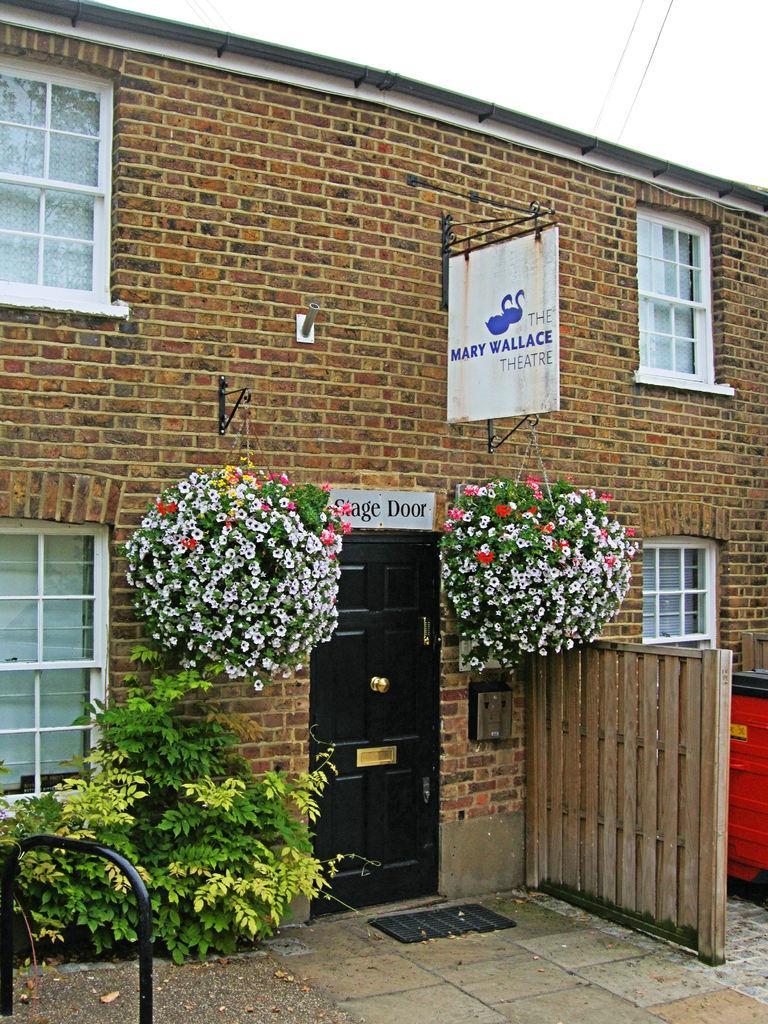Please provide a concise description of this image. In this image I can see a building which is made of bricks, few windows of the building, a white colored board, a tree, the black colored door and few flowers on both sides of the door. To the right bottom of the image I can see a red colored object. 